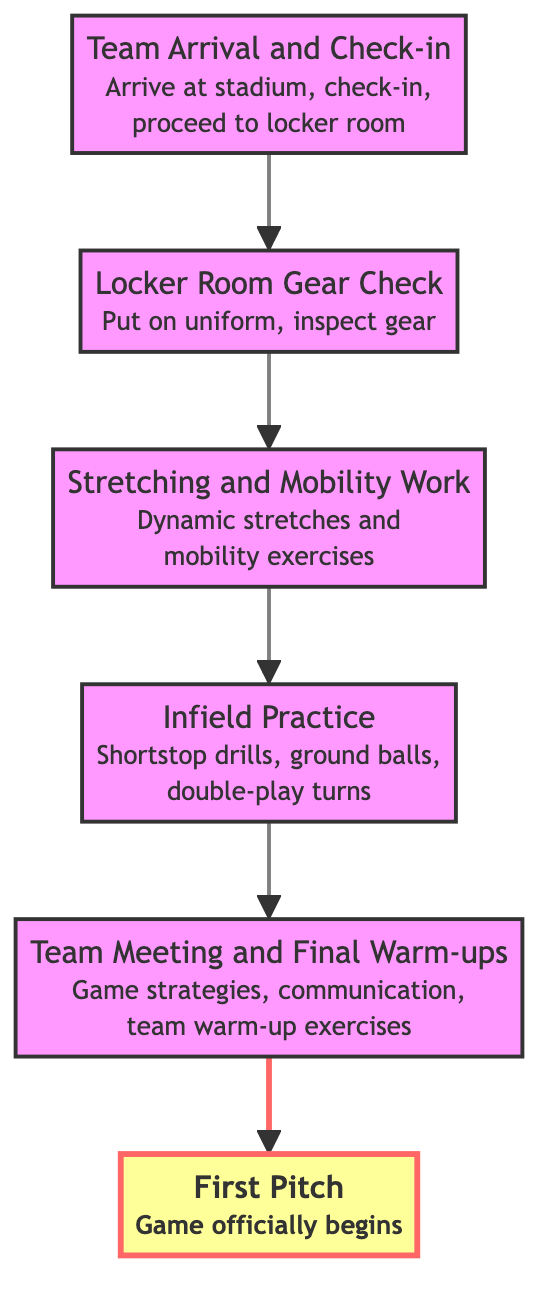What's the first step in the game day preparation? The first step indicated in the diagram is "Team Arrival and Check-in," which is the starting point before all other activities can occur.
Answer: Team Arrival and Check-in How many steps are there in the game day preparation flow? By counting the distinct steps in the diagram, there are six steps leading ultimately to the first pitch.
Answer: Six What follows the Locker Room Gear Check? The diagram shows that the step that immediately follows the Locker Room Gear Check is "Stretching and Mobility Work."
Answer: Stretching and Mobility Work What is the last step before the First Pitch? The flowchart shows that the final step leading up to the First Pitch is "Team Meeting and Final Warm-ups."
Answer: Team Meeting and Final Warm-ups Which step involves specific drills for a shortstop? The diagram points to "Infield Practice" as the step that includes drills specifically for shortstops, such as ground ball practice and double-play turns.
Answer: Infield Practice After Stretching and Mobility Work, what step comes next? According to the flow direction in the chart, the step following Stretching and Mobility Work is "Infield Practice."
Answer: Infield Practice How many distinct activities are completed before the First Pitch? The diagram outlines a sequence of five activities that are completed before reaching the First Pitch.
Answer: Five What preparation is done in the Locker Room Gear Check? In the diagram, the Locker Room Gear Check includes putting on the uniform and inspecting gear like the glove and protective equipment.
Answer: Inspecting gear Which step culminates in the official start of the game? The final step that marks the official start of the game is the "First Pitch," as stated in the diagram.
Answer: First Pitch 